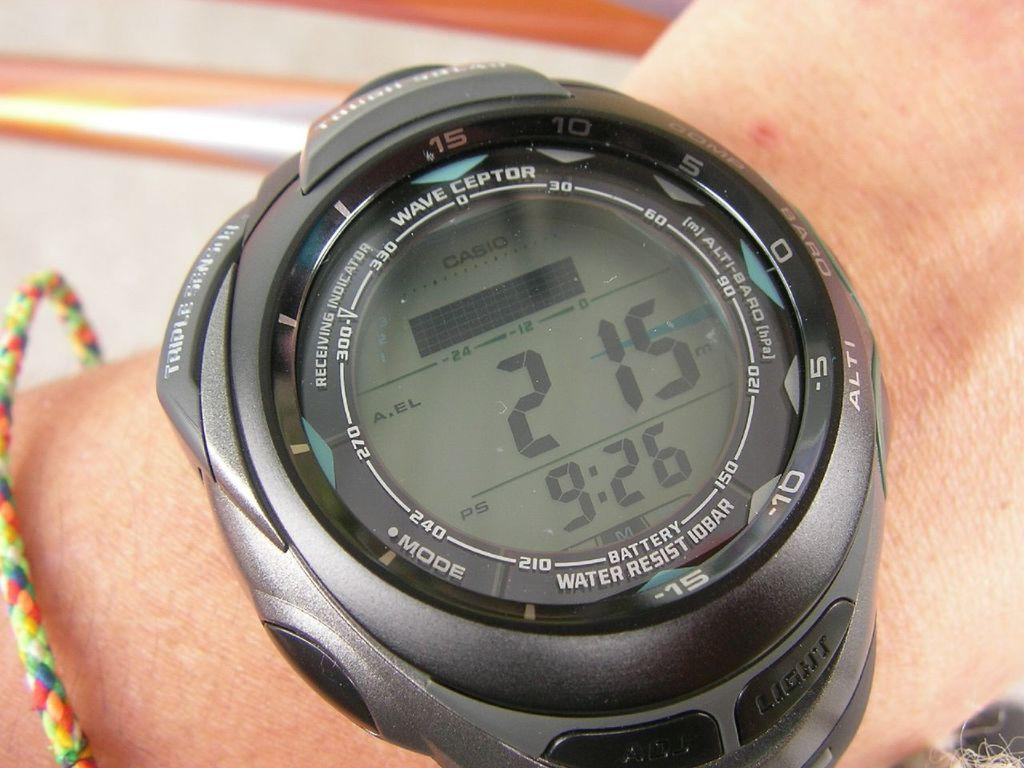<image>
Share a concise interpretation of the image provided. 2 15 is displayed above 9:26 on a watch face. 